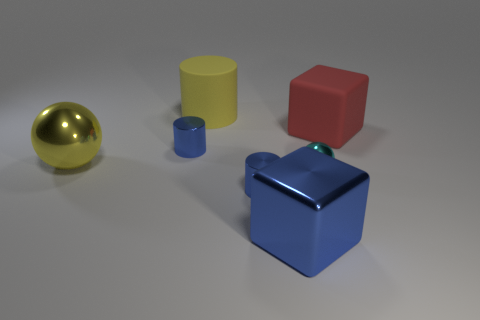Add 1 matte blocks. How many objects exist? 8 Subtract all large matte cylinders. How many cylinders are left? 2 Subtract all purple spheres. How many blue cylinders are left? 2 Subtract all cyan spheres. How many spheres are left? 1 Subtract 1 blue cubes. How many objects are left? 6 Subtract all spheres. How many objects are left? 5 Subtract 2 cubes. How many cubes are left? 0 Subtract all green blocks. Subtract all brown balls. How many blocks are left? 2 Subtract all large purple rubber objects. Subtract all large rubber objects. How many objects are left? 5 Add 2 big rubber cylinders. How many big rubber cylinders are left? 3 